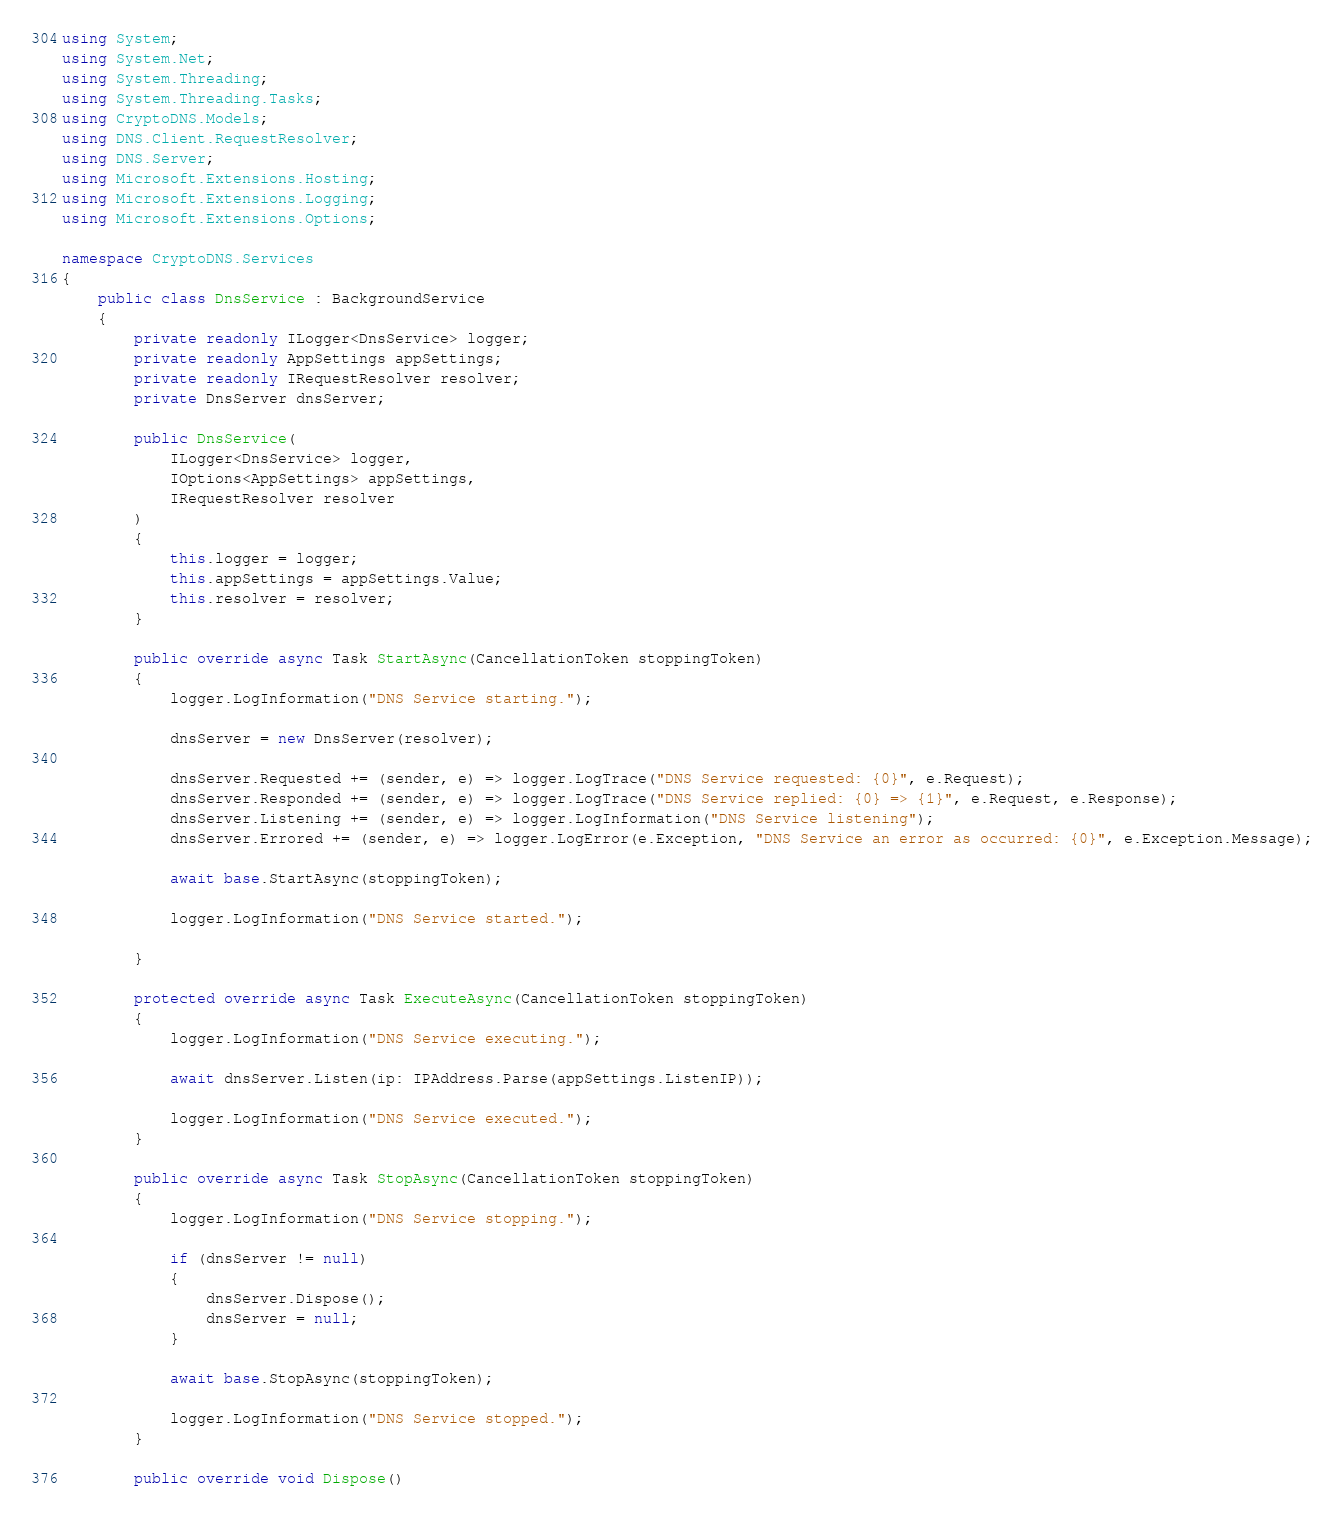Convert code to text. <code><loc_0><loc_0><loc_500><loc_500><_C#_>using System;
using System.Net;
using System.Threading;
using System.Threading.Tasks;
using CryptoDNS.Models;
using DNS.Client.RequestResolver;
using DNS.Server;
using Microsoft.Extensions.Hosting;
using Microsoft.Extensions.Logging;
using Microsoft.Extensions.Options;

namespace CryptoDNS.Services
{
    public class DnsService : BackgroundService
    {
        private readonly ILogger<DnsService> logger;
        private readonly AppSettings appSettings;
        private readonly IRequestResolver resolver;
        private DnsServer dnsServer;

        public DnsService(
            ILogger<DnsService> logger,
            IOptions<AppSettings> appSettings,
            IRequestResolver resolver
        )
        {
            this.logger = logger;
            this.appSettings = appSettings.Value;
            this.resolver = resolver;
        }

        public override async Task StartAsync(CancellationToken stoppingToken)
        {
            logger.LogInformation("DNS Service starting.");

            dnsServer = new DnsServer(resolver);

            dnsServer.Requested += (sender, e) => logger.LogTrace("DNS Service requested: {0}", e.Request);
            dnsServer.Responded += (sender, e) => logger.LogTrace("DNS Service replied: {0} => {1}", e.Request, e.Response);
            dnsServer.Listening += (sender, e) => logger.LogInformation("DNS Service listening");
            dnsServer.Errored += (sender, e) => logger.LogError(e.Exception, "DNS Service an error as occurred: {0}", e.Exception.Message);

            await base.StartAsync(stoppingToken);

            logger.LogInformation("DNS Service started.");
            
        }

        protected override async Task ExecuteAsync(CancellationToken stoppingToken)
        {
            logger.LogInformation("DNS Service executing.");

            await dnsServer.Listen(ip: IPAddress.Parse(appSettings.ListenIP));

            logger.LogInformation("DNS Service executed.");
        }

        public override async Task StopAsync(CancellationToken stoppingToken)
        {
            logger.LogInformation("DNS Service stopping.");

            if (dnsServer != null)
            {
                dnsServer.Dispose();
                dnsServer = null;
            }

            await base.StopAsync(stoppingToken);

            logger.LogInformation("DNS Service stopped.");
        }

        public override void Dispose()</code> 